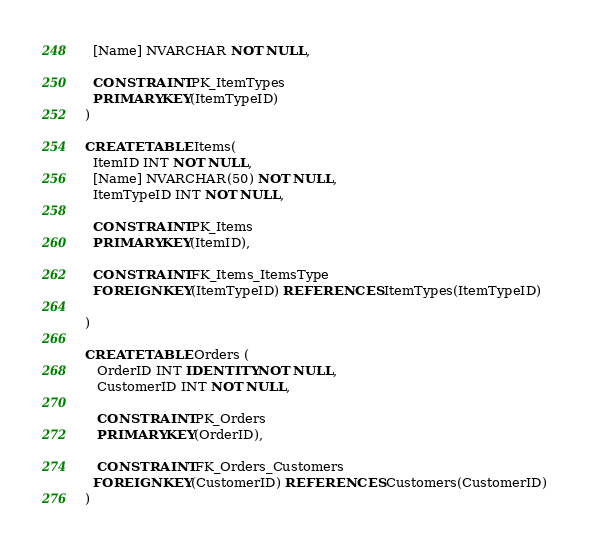<code> <loc_0><loc_0><loc_500><loc_500><_SQL_>  [Name] NVARCHAR NOT NULL,

  CONSTRAINT PK_ItemTypes
  PRIMARY KEY(ItemTypeID)
)

CREATE TABLE Items(
  ItemID INT NOT NULL,
  [Name] NVARCHAR(50) NOT NULL,
  ItemTypeID INT NOT NULL,

  CONSTRAINT PK_Items
  PRIMARY KEY(ItemID),

  CONSTRAINT FK_Items_ItemsType
  FOREIGN KEY(ItemTypeID) REFERENCES ItemTypes(ItemTypeID)

)

CREATE TABLE Orders (
   OrderID INT IDENTITY NOT NULL,
   CustomerID INT NOT NULL,

   CONSTRAINT PK_Orders
   PRIMARY KEY(OrderID),

   CONSTRAINT FK_Orders_Customers
  FOREIGN KEY(CustomerID) REFERENCES Customers(CustomerID)
)



</code> 